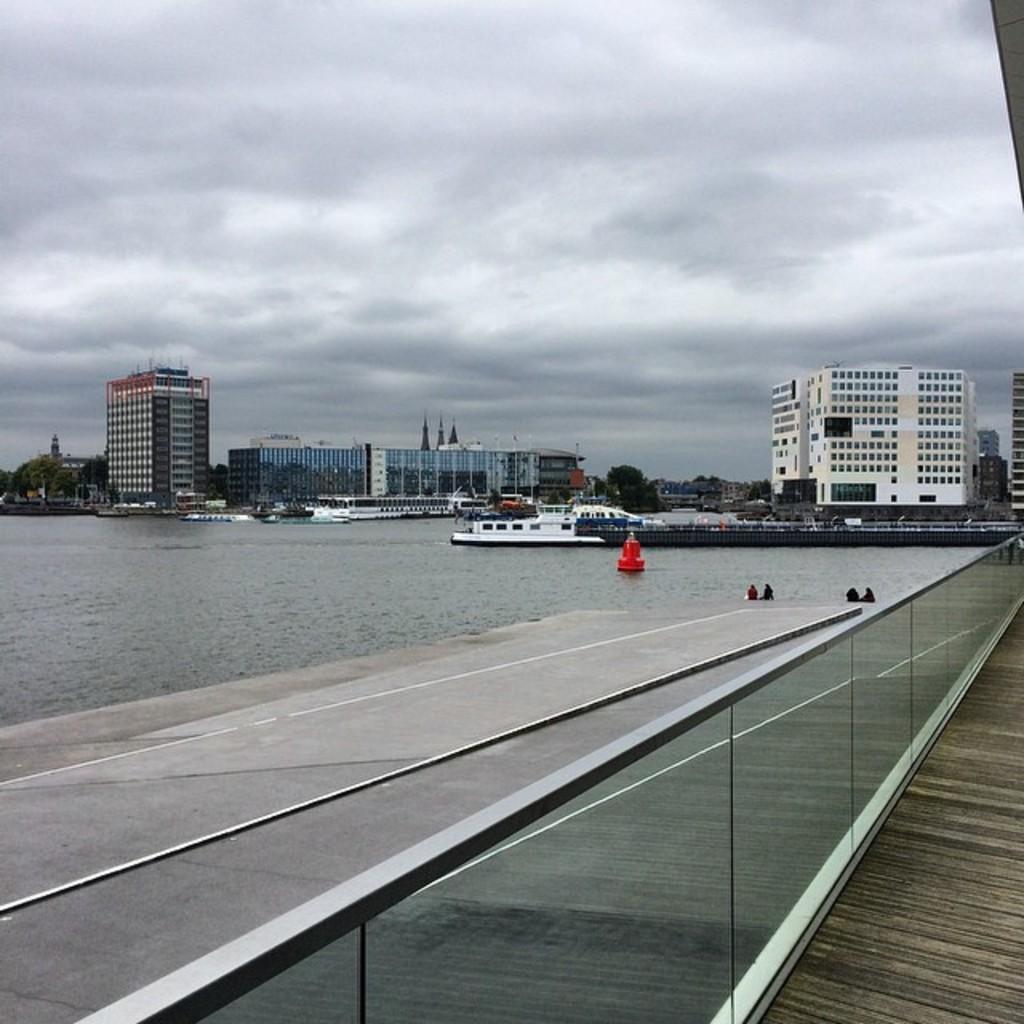Can you describe this image briefly? In this image I can see few boats on the water. In front I can see the glass wall. In the background I can see few buildings in white color and the sky is in white color. 